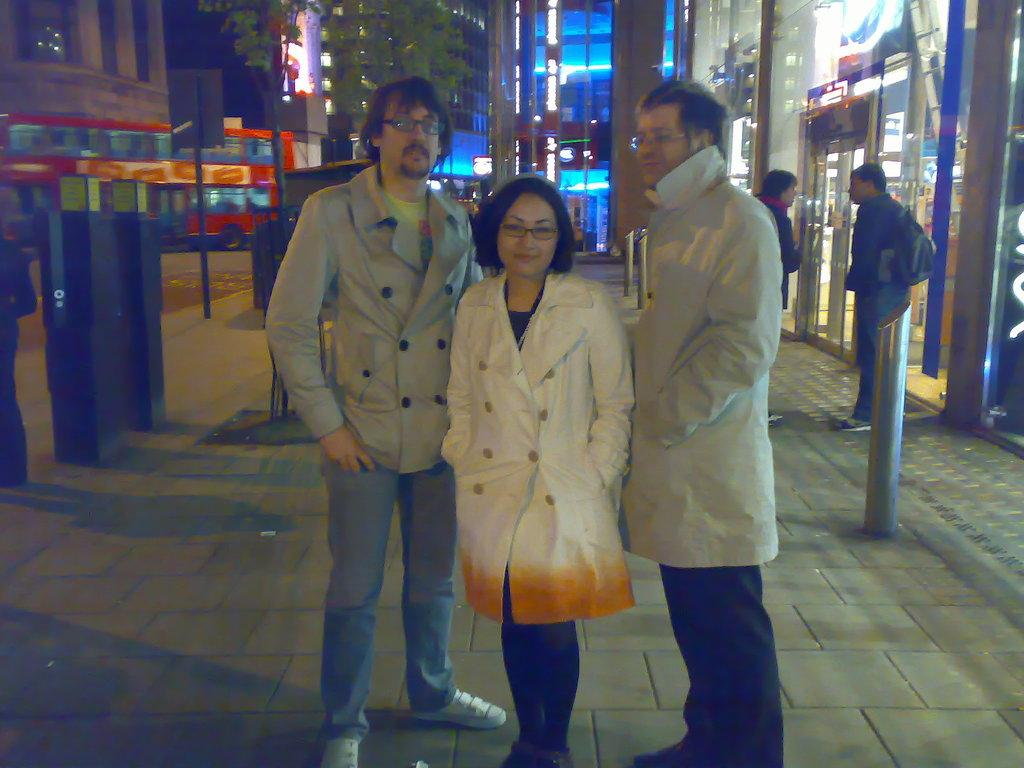What is the main mode of transportation in the image? There is a bus in the image. What type of structures can be seen in the background? There are many buildings in the image. What type of establishments are present in the image? There are stores in the image. What can be observed about the presence of people in the image? There are people standing in the image. What is present on the footpath in the image? There are objects on the footpath in the image. What type of roof can be seen on the bus in the image? There is no specific roof mentioned or visible in the image; it only shows a bus. Can you describe how the people are running in the image? There is no indication of people running in the image; they are simply standing. 